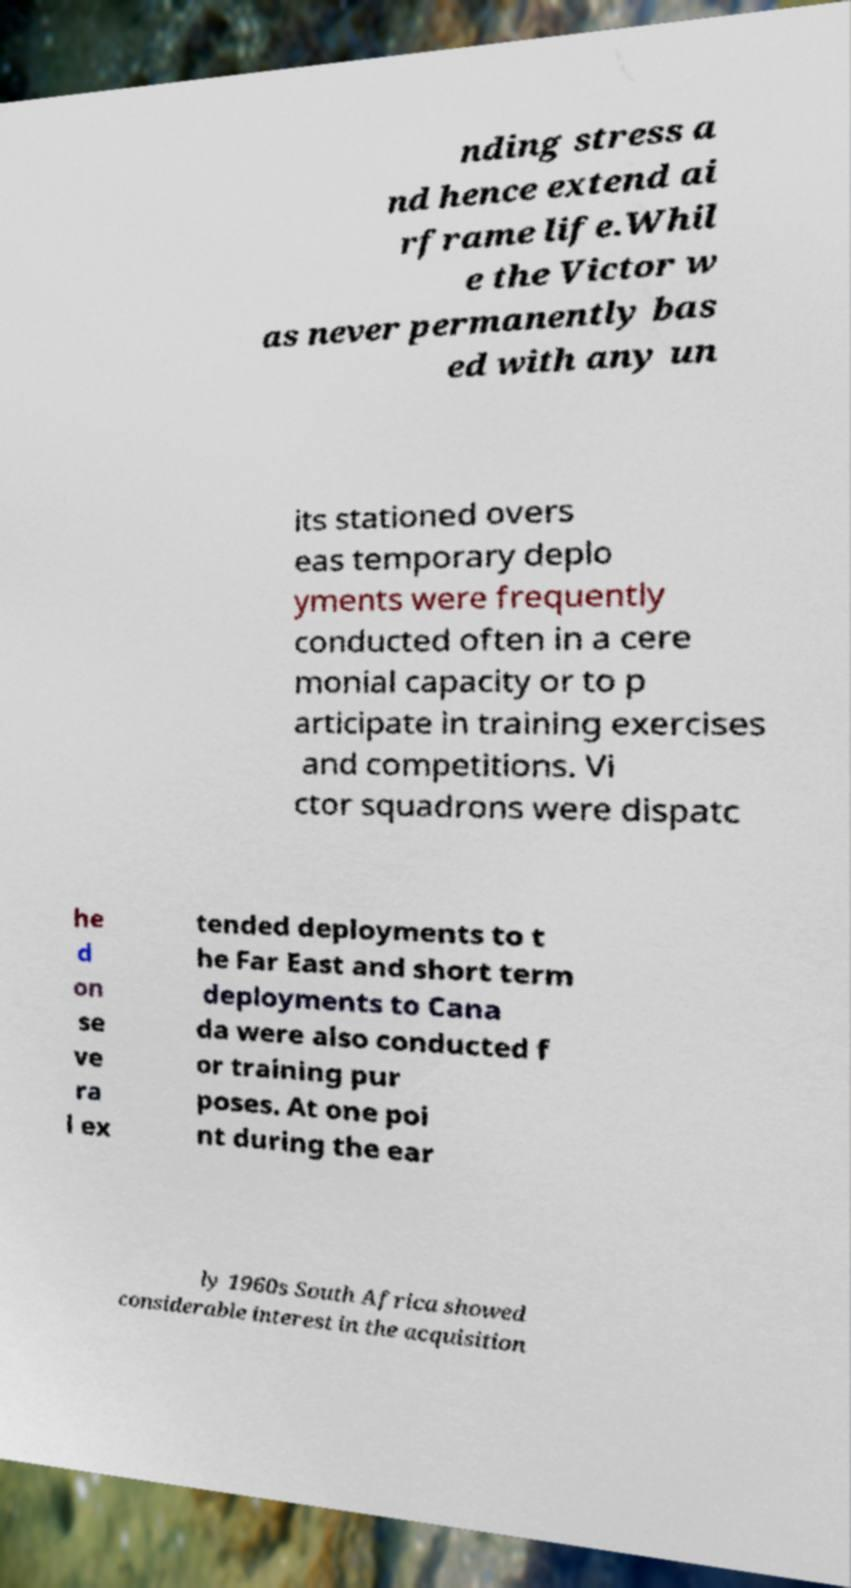Can you read and provide the text displayed in the image?This photo seems to have some interesting text. Can you extract and type it out for me? nding stress a nd hence extend ai rframe life.Whil e the Victor w as never permanently bas ed with any un its stationed overs eas temporary deplo yments were frequently conducted often in a cere monial capacity or to p articipate in training exercises and competitions. Vi ctor squadrons were dispatc he d on se ve ra l ex tended deployments to t he Far East and short term deployments to Cana da were also conducted f or training pur poses. At one poi nt during the ear ly 1960s South Africa showed considerable interest in the acquisition 